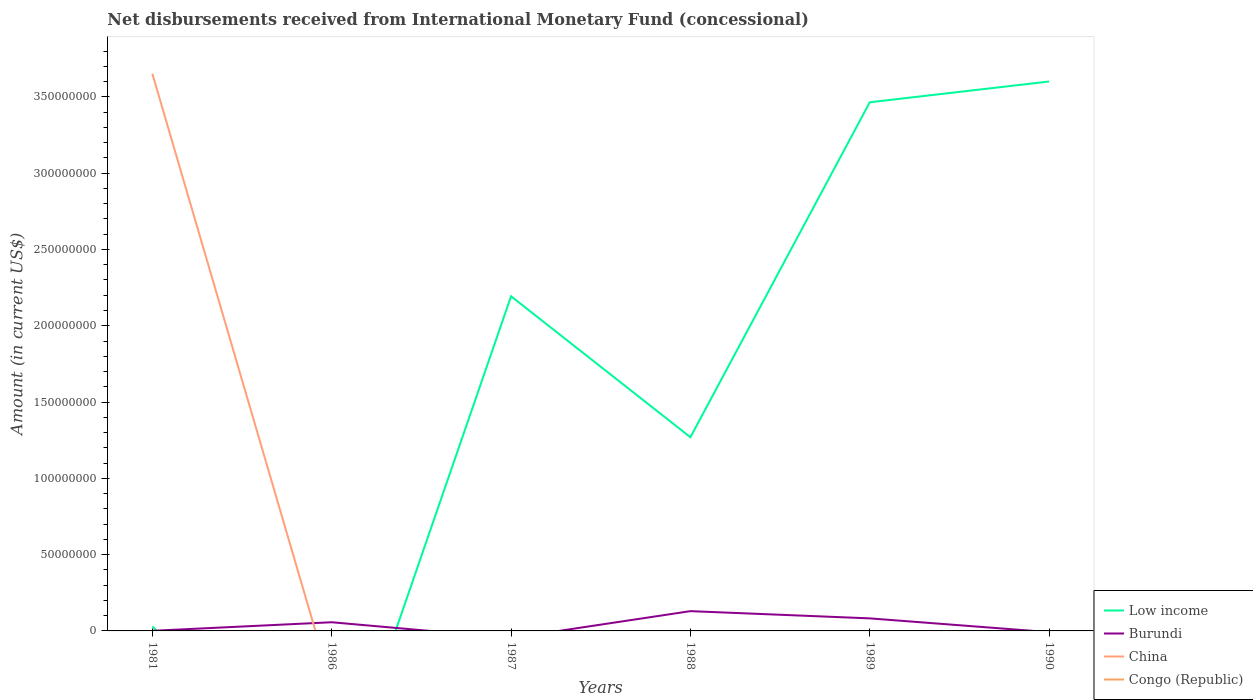How many different coloured lines are there?
Provide a short and direct response. 4. Does the line corresponding to Low income intersect with the line corresponding to Congo (Republic)?
Your answer should be compact. Yes. What is the total amount of disbursements received from International Monetary Fund in Burundi in the graph?
Your answer should be very brief. -7.28e+06. What is the difference between the highest and the second highest amount of disbursements received from International Monetary Fund in China?
Provide a short and direct response. 3.65e+08. What is the difference between the highest and the lowest amount of disbursements received from International Monetary Fund in Burundi?
Give a very brief answer. 3. Is the amount of disbursements received from International Monetary Fund in China strictly greater than the amount of disbursements received from International Monetary Fund in Burundi over the years?
Provide a succinct answer. No. How many lines are there?
Your answer should be compact. 4. Are the values on the major ticks of Y-axis written in scientific E-notation?
Keep it short and to the point. No. Does the graph contain grids?
Provide a short and direct response. No. How are the legend labels stacked?
Your answer should be very brief. Vertical. What is the title of the graph?
Your answer should be very brief. Net disbursements received from International Monetary Fund (concessional). Does "Comoros" appear as one of the legend labels in the graph?
Provide a short and direct response. No. What is the label or title of the X-axis?
Provide a succinct answer. Years. What is the label or title of the Y-axis?
Give a very brief answer. Amount (in current US$). What is the Amount (in current US$) in Low income in 1981?
Provide a succinct answer. 3.02e+06. What is the Amount (in current US$) of Burundi in 1981?
Make the answer very short. 8.50e+04. What is the Amount (in current US$) in China in 1981?
Offer a terse response. 3.65e+08. What is the Amount (in current US$) of Congo (Republic) in 1981?
Your response must be concise. 5.80e+04. What is the Amount (in current US$) in Burundi in 1986?
Give a very brief answer. 5.68e+06. What is the Amount (in current US$) of China in 1986?
Your answer should be compact. 0. What is the Amount (in current US$) in Congo (Republic) in 1986?
Your answer should be very brief. 0. What is the Amount (in current US$) of Low income in 1987?
Make the answer very short. 2.19e+08. What is the Amount (in current US$) of Low income in 1988?
Give a very brief answer. 1.27e+08. What is the Amount (in current US$) of Burundi in 1988?
Give a very brief answer. 1.30e+07. What is the Amount (in current US$) of China in 1988?
Offer a terse response. 0. What is the Amount (in current US$) of Congo (Republic) in 1988?
Ensure brevity in your answer.  0. What is the Amount (in current US$) in Low income in 1989?
Offer a very short reply. 3.46e+08. What is the Amount (in current US$) of Burundi in 1989?
Your response must be concise. 8.22e+06. What is the Amount (in current US$) of Low income in 1990?
Provide a succinct answer. 3.60e+08. What is the Amount (in current US$) in Burundi in 1990?
Provide a short and direct response. 0. What is the Amount (in current US$) of China in 1990?
Your response must be concise. 0. What is the Amount (in current US$) in Congo (Republic) in 1990?
Your response must be concise. 0. Across all years, what is the maximum Amount (in current US$) of Low income?
Your answer should be compact. 3.60e+08. Across all years, what is the maximum Amount (in current US$) of Burundi?
Provide a short and direct response. 1.30e+07. Across all years, what is the maximum Amount (in current US$) in China?
Provide a succinct answer. 3.65e+08. Across all years, what is the maximum Amount (in current US$) in Congo (Republic)?
Provide a succinct answer. 5.80e+04. Across all years, what is the minimum Amount (in current US$) of China?
Offer a very short reply. 0. Across all years, what is the minimum Amount (in current US$) of Congo (Republic)?
Your answer should be compact. 0. What is the total Amount (in current US$) of Low income in the graph?
Your answer should be very brief. 1.06e+09. What is the total Amount (in current US$) in Burundi in the graph?
Provide a succinct answer. 2.70e+07. What is the total Amount (in current US$) of China in the graph?
Keep it short and to the point. 3.65e+08. What is the total Amount (in current US$) of Congo (Republic) in the graph?
Your answer should be very brief. 5.80e+04. What is the difference between the Amount (in current US$) in Burundi in 1981 and that in 1986?
Make the answer very short. -5.60e+06. What is the difference between the Amount (in current US$) in Low income in 1981 and that in 1987?
Your answer should be very brief. -2.16e+08. What is the difference between the Amount (in current US$) of Low income in 1981 and that in 1988?
Make the answer very short. -1.24e+08. What is the difference between the Amount (in current US$) in Burundi in 1981 and that in 1988?
Offer a terse response. -1.29e+07. What is the difference between the Amount (in current US$) in Low income in 1981 and that in 1989?
Offer a terse response. -3.43e+08. What is the difference between the Amount (in current US$) in Burundi in 1981 and that in 1989?
Your answer should be very brief. -8.14e+06. What is the difference between the Amount (in current US$) of Low income in 1981 and that in 1990?
Your answer should be very brief. -3.57e+08. What is the difference between the Amount (in current US$) of Burundi in 1986 and that in 1988?
Offer a terse response. -7.28e+06. What is the difference between the Amount (in current US$) in Burundi in 1986 and that in 1989?
Offer a terse response. -2.54e+06. What is the difference between the Amount (in current US$) of Low income in 1987 and that in 1988?
Make the answer very short. 9.24e+07. What is the difference between the Amount (in current US$) of Low income in 1987 and that in 1989?
Your answer should be compact. -1.27e+08. What is the difference between the Amount (in current US$) in Low income in 1987 and that in 1990?
Give a very brief answer. -1.41e+08. What is the difference between the Amount (in current US$) in Low income in 1988 and that in 1989?
Give a very brief answer. -2.20e+08. What is the difference between the Amount (in current US$) in Burundi in 1988 and that in 1989?
Your answer should be very brief. 4.74e+06. What is the difference between the Amount (in current US$) in Low income in 1988 and that in 1990?
Ensure brevity in your answer.  -2.33e+08. What is the difference between the Amount (in current US$) of Low income in 1989 and that in 1990?
Ensure brevity in your answer.  -1.36e+07. What is the difference between the Amount (in current US$) of Low income in 1981 and the Amount (in current US$) of Burundi in 1986?
Offer a terse response. -2.67e+06. What is the difference between the Amount (in current US$) in Low income in 1981 and the Amount (in current US$) in Burundi in 1988?
Provide a succinct answer. -9.95e+06. What is the difference between the Amount (in current US$) in Low income in 1981 and the Amount (in current US$) in Burundi in 1989?
Your answer should be very brief. -5.21e+06. What is the difference between the Amount (in current US$) in Low income in 1987 and the Amount (in current US$) in Burundi in 1988?
Make the answer very short. 2.06e+08. What is the difference between the Amount (in current US$) in Low income in 1987 and the Amount (in current US$) in Burundi in 1989?
Ensure brevity in your answer.  2.11e+08. What is the difference between the Amount (in current US$) in Low income in 1988 and the Amount (in current US$) in Burundi in 1989?
Offer a very short reply. 1.19e+08. What is the average Amount (in current US$) in Low income per year?
Your response must be concise. 1.76e+08. What is the average Amount (in current US$) of Burundi per year?
Your answer should be very brief. 4.49e+06. What is the average Amount (in current US$) in China per year?
Provide a succinct answer. 6.09e+07. What is the average Amount (in current US$) of Congo (Republic) per year?
Offer a terse response. 9666.67. In the year 1981, what is the difference between the Amount (in current US$) in Low income and Amount (in current US$) in Burundi?
Offer a very short reply. 2.93e+06. In the year 1981, what is the difference between the Amount (in current US$) in Low income and Amount (in current US$) in China?
Keep it short and to the point. -3.62e+08. In the year 1981, what is the difference between the Amount (in current US$) in Low income and Amount (in current US$) in Congo (Republic)?
Provide a short and direct response. 2.96e+06. In the year 1981, what is the difference between the Amount (in current US$) of Burundi and Amount (in current US$) of China?
Offer a very short reply. -3.65e+08. In the year 1981, what is the difference between the Amount (in current US$) of Burundi and Amount (in current US$) of Congo (Republic)?
Provide a short and direct response. 2.70e+04. In the year 1981, what is the difference between the Amount (in current US$) in China and Amount (in current US$) in Congo (Republic)?
Ensure brevity in your answer.  3.65e+08. In the year 1988, what is the difference between the Amount (in current US$) in Low income and Amount (in current US$) in Burundi?
Your response must be concise. 1.14e+08. In the year 1989, what is the difference between the Amount (in current US$) of Low income and Amount (in current US$) of Burundi?
Your response must be concise. 3.38e+08. What is the ratio of the Amount (in current US$) of Burundi in 1981 to that in 1986?
Provide a succinct answer. 0.01. What is the ratio of the Amount (in current US$) of Low income in 1981 to that in 1987?
Keep it short and to the point. 0.01. What is the ratio of the Amount (in current US$) in Low income in 1981 to that in 1988?
Keep it short and to the point. 0.02. What is the ratio of the Amount (in current US$) of Burundi in 1981 to that in 1988?
Give a very brief answer. 0.01. What is the ratio of the Amount (in current US$) of Low income in 1981 to that in 1989?
Your answer should be compact. 0.01. What is the ratio of the Amount (in current US$) of Burundi in 1981 to that in 1989?
Your response must be concise. 0.01. What is the ratio of the Amount (in current US$) of Low income in 1981 to that in 1990?
Your answer should be compact. 0.01. What is the ratio of the Amount (in current US$) in Burundi in 1986 to that in 1988?
Provide a succinct answer. 0.44. What is the ratio of the Amount (in current US$) of Burundi in 1986 to that in 1989?
Offer a very short reply. 0.69. What is the ratio of the Amount (in current US$) in Low income in 1987 to that in 1988?
Your answer should be very brief. 1.73. What is the ratio of the Amount (in current US$) in Low income in 1987 to that in 1989?
Your response must be concise. 0.63. What is the ratio of the Amount (in current US$) in Low income in 1987 to that in 1990?
Offer a very short reply. 0.61. What is the ratio of the Amount (in current US$) in Low income in 1988 to that in 1989?
Offer a very short reply. 0.37. What is the ratio of the Amount (in current US$) in Burundi in 1988 to that in 1989?
Offer a terse response. 1.58. What is the ratio of the Amount (in current US$) in Low income in 1988 to that in 1990?
Offer a terse response. 0.35. What is the ratio of the Amount (in current US$) of Low income in 1989 to that in 1990?
Make the answer very short. 0.96. What is the difference between the highest and the second highest Amount (in current US$) in Low income?
Your answer should be very brief. 1.36e+07. What is the difference between the highest and the second highest Amount (in current US$) of Burundi?
Your response must be concise. 4.74e+06. What is the difference between the highest and the lowest Amount (in current US$) of Low income?
Give a very brief answer. 3.60e+08. What is the difference between the highest and the lowest Amount (in current US$) in Burundi?
Make the answer very short. 1.30e+07. What is the difference between the highest and the lowest Amount (in current US$) in China?
Provide a short and direct response. 3.65e+08. What is the difference between the highest and the lowest Amount (in current US$) in Congo (Republic)?
Ensure brevity in your answer.  5.80e+04. 